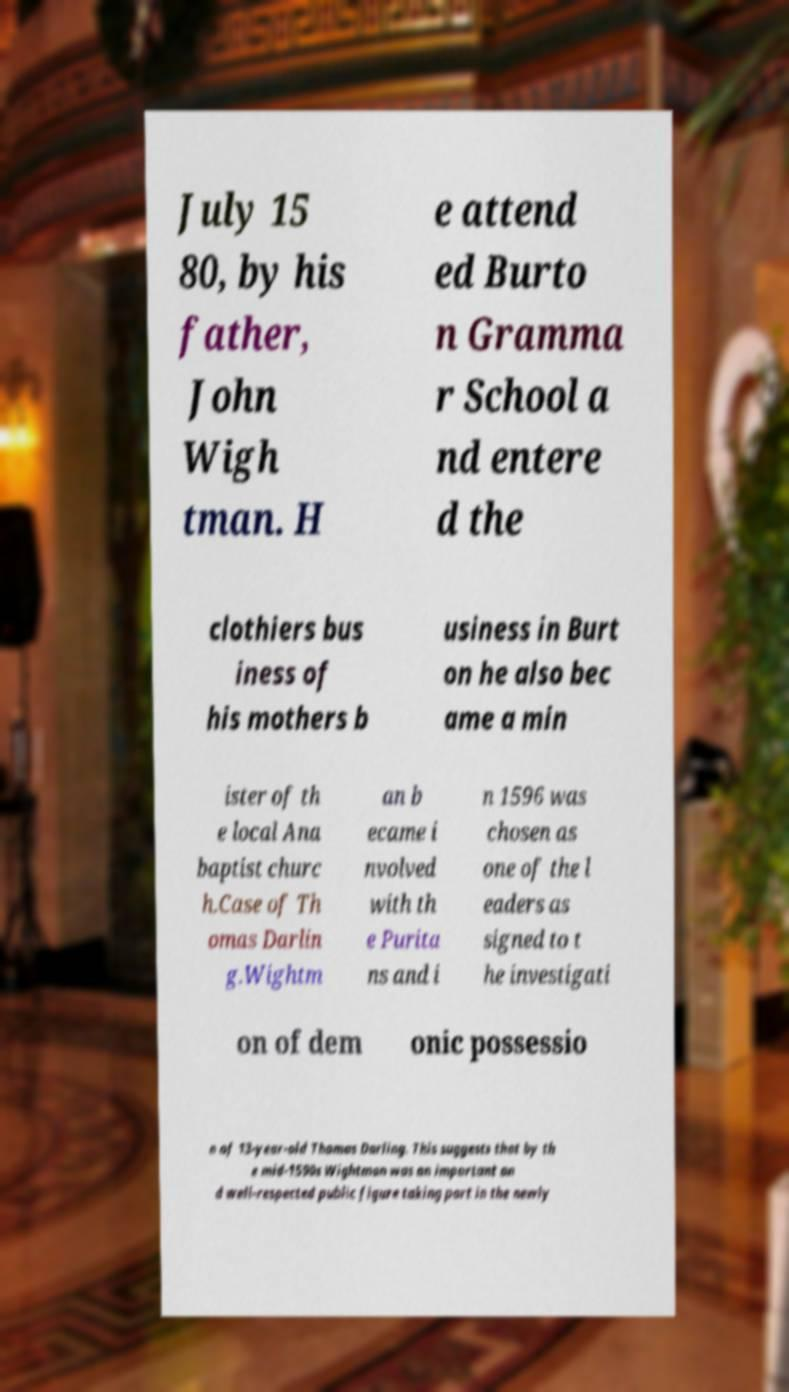Could you extract and type out the text from this image? July 15 80, by his father, John Wigh tman. H e attend ed Burto n Gramma r School a nd entere d the clothiers bus iness of his mothers b usiness in Burt on he also bec ame a min ister of th e local Ana baptist churc h.Case of Th omas Darlin g.Wightm an b ecame i nvolved with th e Purita ns and i n 1596 was chosen as one of the l eaders as signed to t he investigati on of dem onic possessio n of 13-year-old Thomas Darling. This suggests that by th e mid-1590s Wightman was an important an d well-respected public figure taking part in the newly 